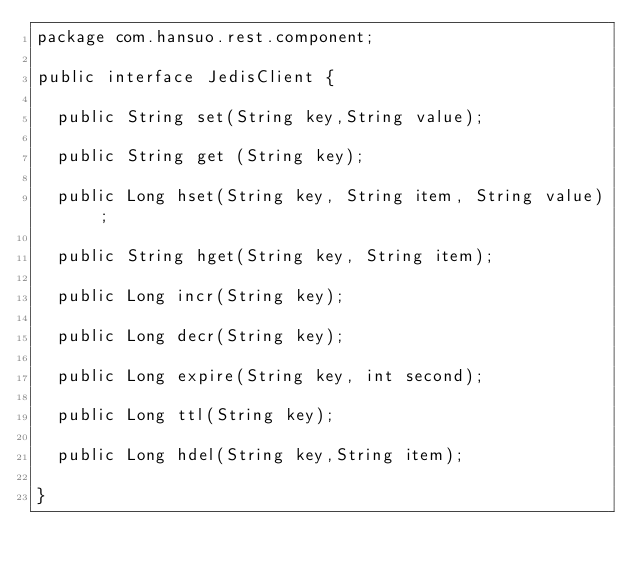Convert code to text. <code><loc_0><loc_0><loc_500><loc_500><_Java_>package com.hansuo.rest.component;

public interface JedisClient {

	public String set(String key,String value);
	
	public String get (String key);
	
	public Long hset(String key, String item, String value) ;
	
	public String hget(String key, String item);
	
	public Long incr(String key);
	
	public Long decr(String key);
	
	public Long expire(String key, int second);
	
	public Long ttl(String key);
	
	public Long hdel(String key,String item);
	
}
</code> 